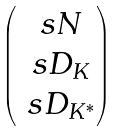Convert formula to latex. <formula><loc_0><loc_0><loc_500><loc_500>\begin{pmatrix} \ s N \\ \ s D _ { K } \\ \ s D _ { K ^ { * } } \end{pmatrix}</formula> 